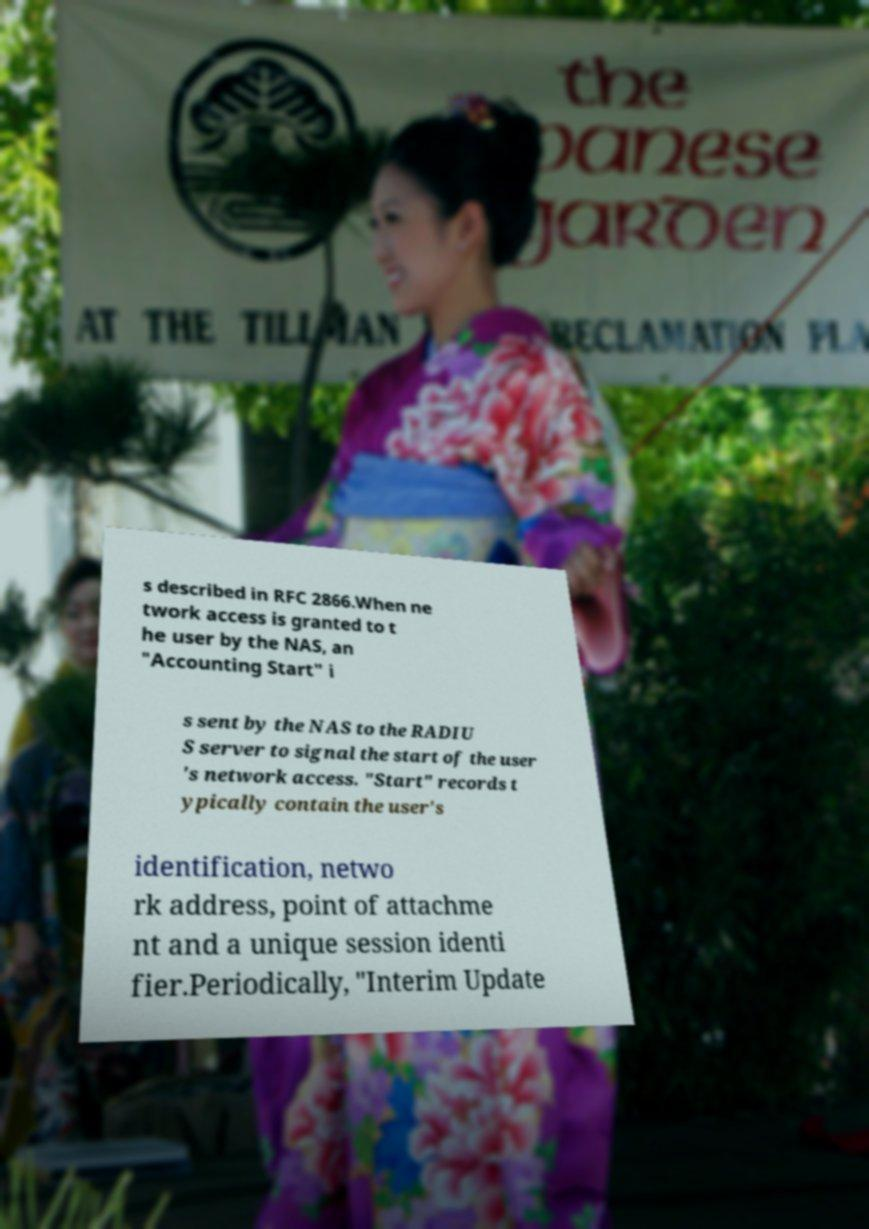Can you accurately transcribe the text from the provided image for me? s described in RFC 2866.When ne twork access is granted to t he user by the NAS, an "Accounting Start" i s sent by the NAS to the RADIU S server to signal the start of the user 's network access. "Start" records t ypically contain the user's identification, netwo rk address, point of attachme nt and a unique session identi fier.Periodically, "Interim Update 